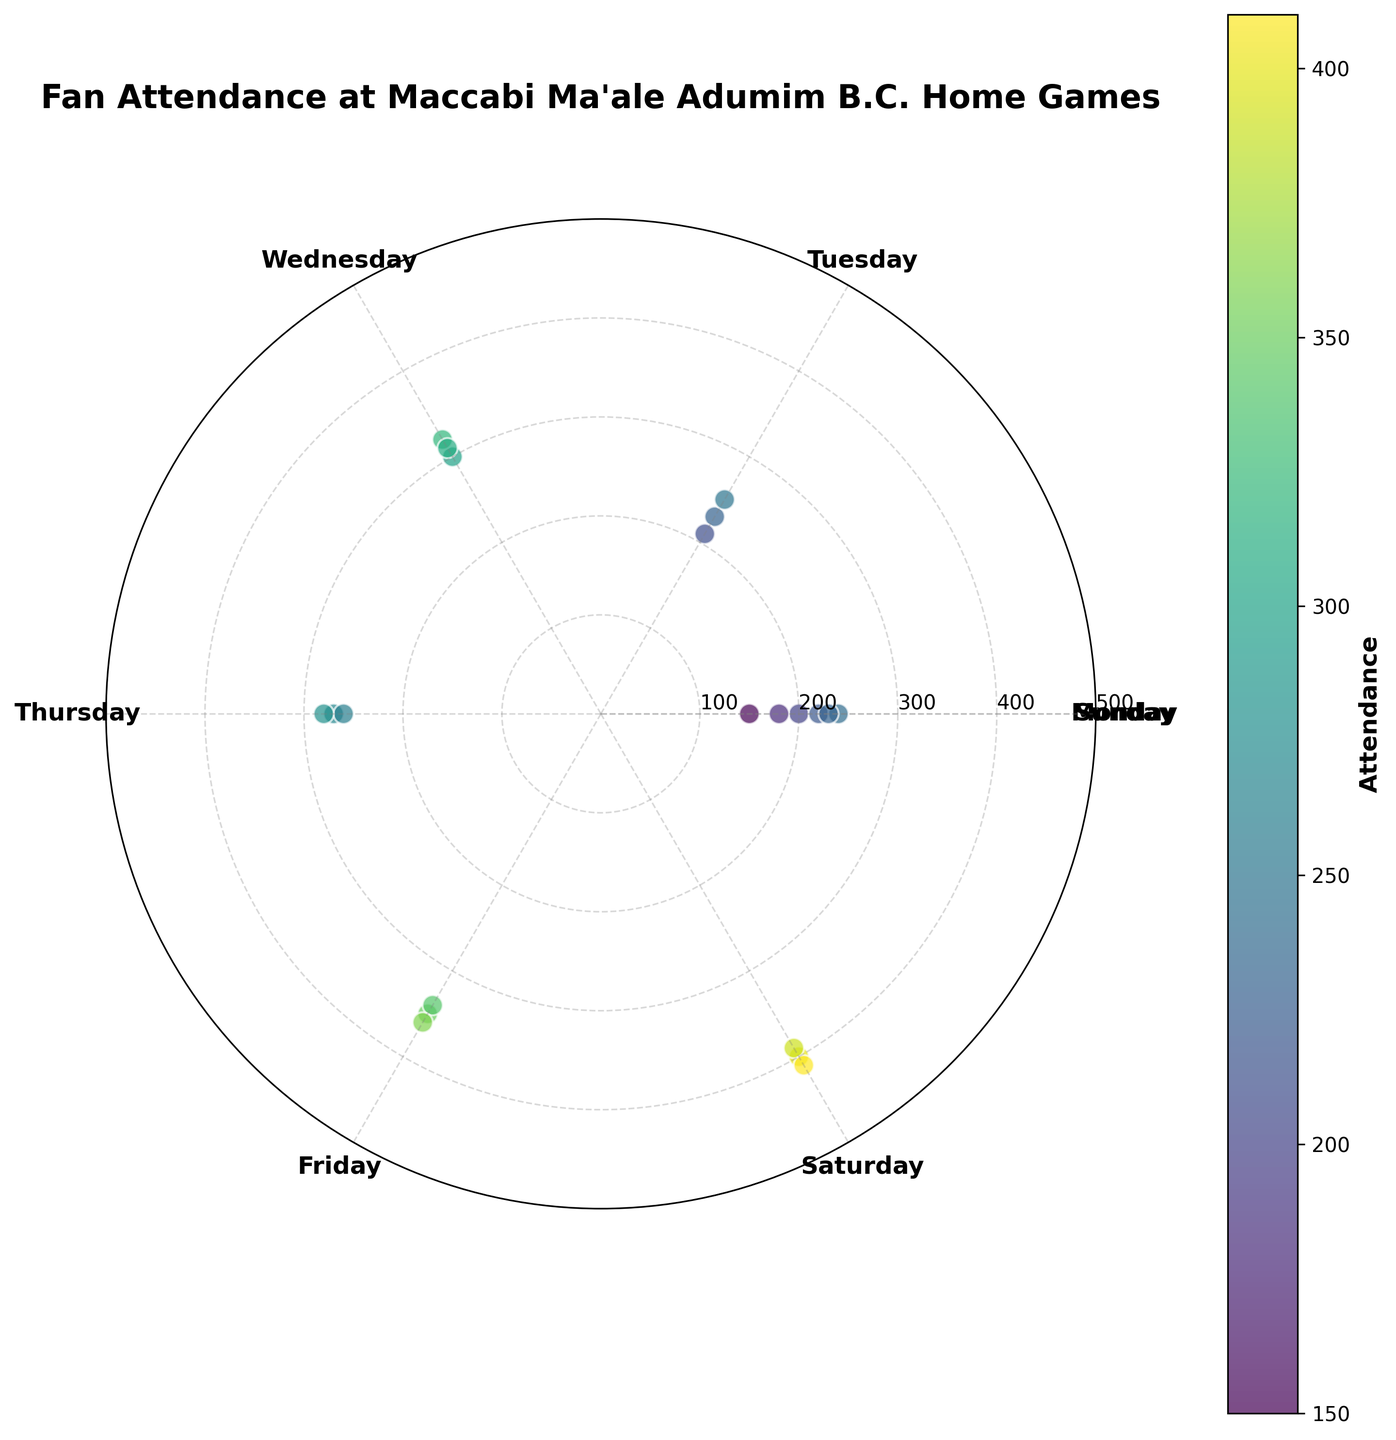What's the maximum attendance seen in the figure? First, identify the highest value on the attendance scale. In this case, it reaches up to 410, indicating the maximum attendance.
Answer: 410 How many data points represent attendance on Saturdays? Look at the scatter points around the angle corresponding to Saturday (5π/3). There are three points, representing three attendance values.
Answer: 3 Which day of the week shows the highest range of attendance? Calculate the range for each day by finding the difference between the maximum and minimum attendance points for that day. Saturday shows values from 390 to 410, resulting in the highest range of 20.
Answer: Saturday What's the average attendance on Fridays? Locate the points around Friday (4π/3) and find their values (350, 340, 360). Sum these values (350+340+360=1050) and divide by the number of points (3).
Answer: 350 Is the attendance generally higher on weekends compared to weekdays? Observe the scatter points' distribution. Weekend days (Saturday and Sunday) have higher attendance values (390-410 for Saturday, 220-240 for Sunday) compared to lower ranges on weekdays.
Answer: Yes What is the attendance range for Monday? Find the minimum and maximum attendance for Monday (150 to 200), then calculate the range (200-150).
Answer: 50 Does Wednesday have a higher average attendance than Tuesday? Calculate Tuesday's average attendance (230+210+250)/3 = 230; and Wednesday's average attendance (300+320+310)/3 = 310. Compare the two averages.
Answer: Yes How many days have an attendance point greater than 300? Identify days where any point is above 300: Wednesday, Friday, and Saturday, totaling three days.
Answer: 3 What is the color distribution appearance for the highest attendances in the figure? The colorbar indicates higher attendance points are marked in a yellowish hue, signifying a range closer to 400-410.
Answer: Yellow What's the median attendance on Sundays? List Sunday’s attendance values (220, 230, 240). Sorting these gives (220, 230, 240), making the middle value the median.
Answer: 230 